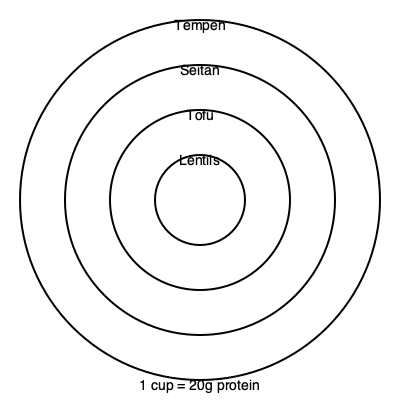The circles in the image represent the portion sizes of different plant-based protein sources needed to obtain 20g of protein. If the largest circle represents 1 cup of lentils, estimate the volume of tempeh (smallest circle) required to achieve the same amount of protein. To solve this problem, we need to follow these steps:

1. Understand the given information:
   - The largest circle represents 1 cup of lentils, providing 20g of protein.
   - The smallest circle represents tempeh.
   - The circles are scaled according to the portion sizes needed for 20g of protein.

2. Analyze the relative sizes of the circles:
   - There are four circles, representing lentils, tofu, seitan, and tempeh (from largest to smallest).
   - The tempeh circle is approximately 1/4 the diameter of the lentils circle.

3. Calculate the volume relationship:
   - Volume is proportional to the cube of the diameter (or radius).
   - If the diameter is 1/4, the volume will be $(1/4)^3 = 1/64$ of the original volume.

4. Determine the volume of tempeh:
   - 1 cup of lentils = 20g protein
   - Tempeh volume = $1 \text{ cup} \times (1/64) = 1/64 \text{ cup}$

5. Convert to a more practical measurement:
   - 1 cup = 16 tablespoons
   - $1/64 \text{ cup} = 16 \div 64 = 1/4 \text{ tablespoon}$

Therefore, approximately 1/4 tablespoon of tempeh provides the same amount of protein as 1 cup of lentils (20g).
Answer: 1/4 tablespoon 